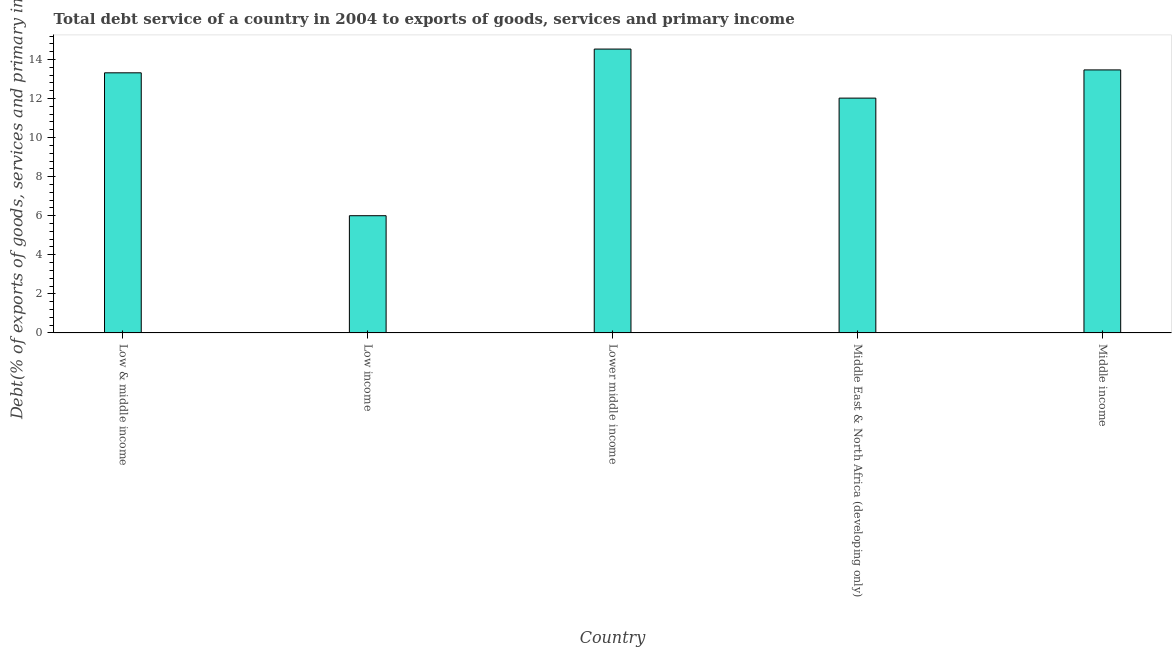Does the graph contain grids?
Ensure brevity in your answer.  No. What is the title of the graph?
Keep it short and to the point. Total debt service of a country in 2004 to exports of goods, services and primary income. What is the label or title of the Y-axis?
Provide a succinct answer. Debt(% of exports of goods, services and primary income). What is the total debt service in Middle income?
Give a very brief answer. 13.47. Across all countries, what is the maximum total debt service?
Offer a very short reply. 14.53. Across all countries, what is the minimum total debt service?
Give a very brief answer. 6. In which country was the total debt service maximum?
Make the answer very short. Lower middle income. In which country was the total debt service minimum?
Ensure brevity in your answer.  Low income. What is the sum of the total debt service?
Offer a very short reply. 59.34. What is the difference between the total debt service in Low & middle income and Low income?
Your answer should be compact. 7.32. What is the average total debt service per country?
Provide a short and direct response. 11.87. What is the median total debt service?
Your answer should be very brief. 13.32. In how many countries, is the total debt service greater than 3.2 %?
Your response must be concise. 5. What is the ratio of the total debt service in Low & middle income to that in Lower middle income?
Your answer should be compact. 0.92. Is the total debt service in Lower middle income less than that in Middle income?
Ensure brevity in your answer.  No. Is the difference between the total debt service in Low income and Lower middle income greater than the difference between any two countries?
Offer a very short reply. Yes. What is the difference between the highest and the second highest total debt service?
Provide a succinct answer. 1.07. What is the difference between the highest and the lowest total debt service?
Your response must be concise. 8.53. In how many countries, is the total debt service greater than the average total debt service taken over all countries?
Make the answer very short. 4. Are all the bars in the graph horizontal?
Offer a terse response. No. How many countries are there in the graph?
Give a very brief answer. 5. What is the Debt(% of exports of goods, services and primary income) in Low & middle income?
Your response must be concise. 13.32. What is the Debt(% of exports of goods, services and primary income) in Low income?
Offer a very short reply. 6. What is the Debt(% of exports of goods, services and primary income) in Lower middle income?
Offer a terse response. 14.53. What is the Debt(% of exports of goods, services and primary income) of Middle East & North Africa (developing only)?
Ensure brevity in your answer.  12.02. What is the Debt(% of exports of goods, services and primary income) in Middle income?
Your response must be concise. 13.47. What is the difference between the Debt(% of exports of goods, services and primary income) in Low & middle income and Low income?
Give a very brief answer. 7.32. What is the difference between the Debt(% of exports of goods, services and primary income) in Low & middle income and Lower middle income?
Give a very brief answer. -1.22. What is the difference between the Debt(% of exports of goods, services and primary income) in Low & middle income and Middle East & North Africa (developing only)?
Provide a succinct answer. 1.29. What is the difference between the Debt(% of exports of goods, services and primary income) in Low & middle income and Middle income?
Your response must be concise. -0.15. What is the difference between the Debt(% of exports of goods, services and primary income) in Low income and Lower middle income?
Make the answer very short. -8.53. What is the difference between the Debt(% of exports of goods, services and primary income) in Low income and Middle East & North Africa (developing only)?
Keep it short and to the point. -6.02. What is the difference between the Debt(% of exports of goods, services and primary income) in Low income and Middle income?
Provide a succinct answer. -7.46. What is the difference between the Debt(% of exports of goods, services and primary income) in Lower middle income and Middle East & North Africa (developing only)?
Provide a succinct answer. 2.51. What is the difference between the Debt(% of exports of goods, services and primary income) in Lower middle income and Middle income?
Your response must be concise. 1.07. What is the difference between the Debt(% of exports of goods, services and primary income) in Middle East & North Africa (developing only) and Middle income?
Your answer should be compact. -1.44. What is the ratio of the Debt(% of exports of goods, services and primary income) in Low & middle income to that in Low income?
Offer a terse response. 2.22. What is the ratio of the Debt(% of exports of goods, services and primary income) in Low & middle income to that in Lower middle income?
Provide a short and direct response. 0.92. What is the ratio of the Debt(% of exports of goods, services and primary income) in Low & middle income to that in Middle East & North Africa (developing only)?
Give a very brief answer. 1.11. What is the ratio of the Debt(% of exports of goods, services and primary income) in Low & middle income to that in Middle income?
Offer a terse response. 0.99. What is the ratio of the Debt(% of exports of goods, services and primary income) in Low income to that in Lower middle income?
Keep it short and to the point. 0.41. What is the ratio of the Debt(% of exports of goods, services and primary income) in Low income to that in Middle East & North Africa (developing only)?
Offer a very short reply. 0.5. What is the ratio of the Debt(% of exports of goods, services and primary income) in Low income to that in Middle income?
Your response must be concise. 0.45. What is the ratio of the Debt(% of exports of goods, services and primary income) in Lower middle income to that in Middle East & North Africa (developing only)?
Ensure brevity in your answer.  1.21. What is the ratio of the Debt(% of exports of goods, services and primary income) in Lower middle income to that in Middle income?
Provide a short and direct response. 1.08. What is the ratio of the Debt(% of exports of goods, services and primary income) in Middle East & North Africa (developing only) to that in Middle income?
Provide a succinct answer. 0.89. 